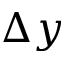Convert formula to latex. <formula><loc_0><loc_0><loc_500><loc_500>\Delta y</formula> 